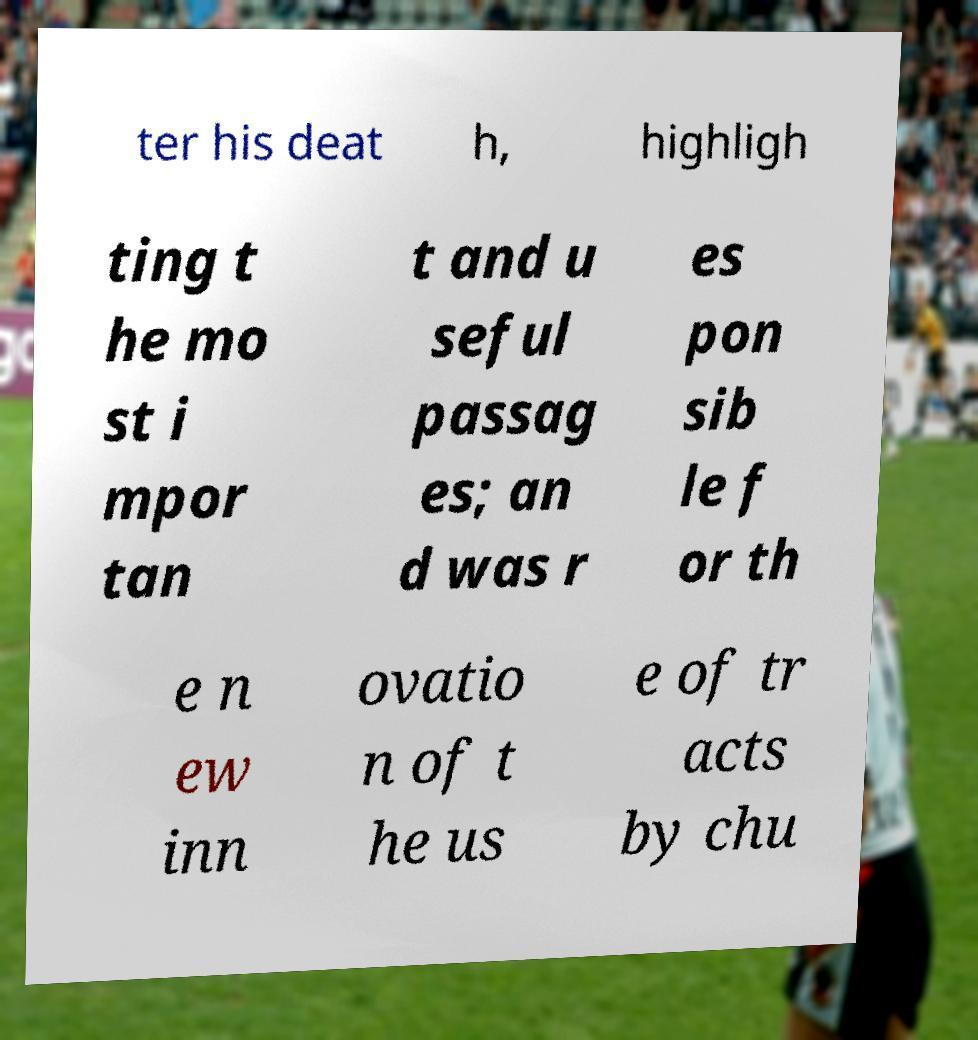Can you read and provide the text displayed in the image?This photo seems to have some interesting text. Can you extract and type it out for me? ter his deat h, highligh ting t he mo st i mpor tan t and u seful passag es; an d was r es pon sib le f or th e n ew inn ovatio n of t he us e of tr acts by chu 